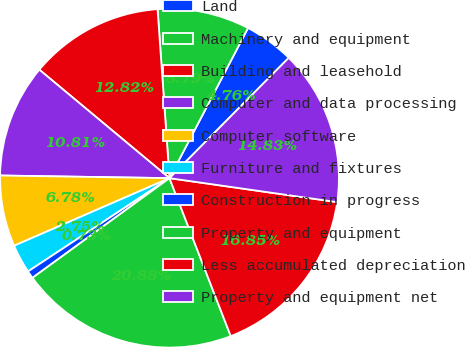Convert chart to OTSL. <chart><loc_0><loc_0><loc_500><loc_500><pie_chart><fcel>Land<fcel>Machinery and equipment<fcel>Building and leasehold<fcel>Computer and data processing<fcel>Computer software<fcel>Furniture and fixtures<fcel>Construction in progress<fcel>Property and equipment<fcel>Less accumulated depreciation<fcel>Property and equipment net<nl><fcel>4.76%<fcel>8.79%<fcel>12.82%<fcel>10.81%<fcel>6.78%<fcel>2.75%<fcel>0.73%<fcel>20.88%<fcel>16.85%<fcel>14.83%<nl></chart> 